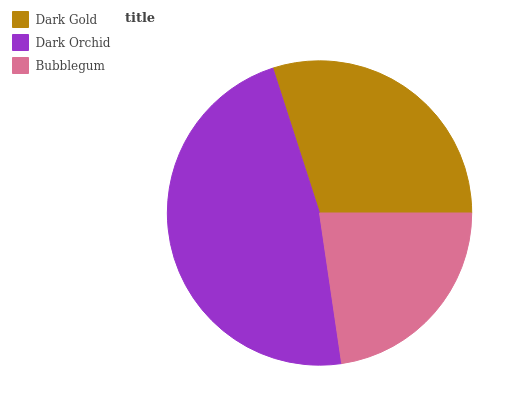Is Bubblegum the minimum?
Answer yes or no. Yes. Is Dark Orchid the maximum?
Answer yes or no. Yes. Is Dark Orchid the minimum?
Answer yes or no. No. Is Bubblegum the maximum?
Answer yes or no. No. Is Dark Orchid greater than Bubblegum?
Answer yes or no. Yes. Is Bubblegum less than Dark Orchid?
Answer yes or no. Yes. Is Bubblegum greater than Dark Orchid?
Answer yes or no. No. Is Dark Orchid less than Bubblegum?
Answer yes or no. No. Is Dark Gold the high median?
Answer yes or no. Yes. Is Dark Gold the low median?
Answer yes or no. Yes. Is Dark Orchid the high median?
Answer yes or no. No. Is Bubblegum the low median?
Answer yes or no. No. 